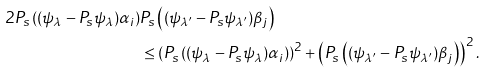Convert formula to latex. <formula><loc_0><loc_0><loc_500><loc_500>2 P _ { s } \left ( ( \psi _ { \lambda } - P _ { s } \psi _ { \lambda } ) \alpha _ { i } \right ) & P _ { s } \left ( ( \psi _ { \lambda ^ { \prime } } - P _ { s } \psi _ { \lambda ^ { \prime } } ) \beta _ { j } \right ) \\ & \leq \left ( P _ { s } \left ( ( \psi _ { \lambda } - P _ { s } \psi _ { \lambda } ) \alpha _ { i } \right ) \right ) ^ { 2 } + \left ( P _ { s } \left ( ( \psi _ { \lambda ^ { \prime } } - P _ { s } \psi _ { \lambda ^ { \prime } } ) \beta _ { j } \right ) \right ) ^ { 2 } .</formula> 